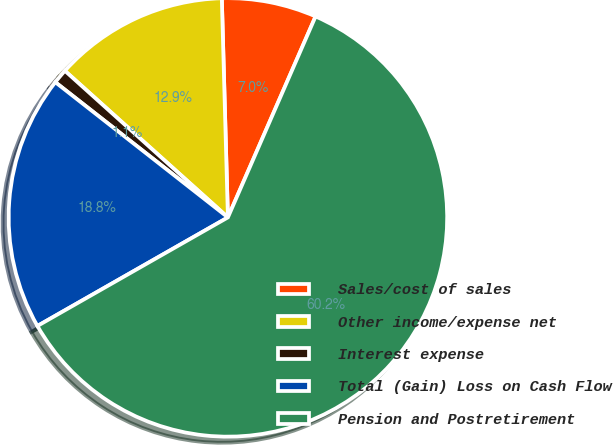<chart> <loc_0><loc_0><loc_500><loc_500><pie_chart><fcel>Sales/cost of sales<fcel>Other income/expense net<fcel>Interest expense<fcel>Total (Gain) Loss on Cash Flow<fcel>Pension and Postretirement<nl><fcel>6.99%<fcel>12.9%<fcel>1.08%<fcel>18.82%<fcel>60.21%<nl></chart> 